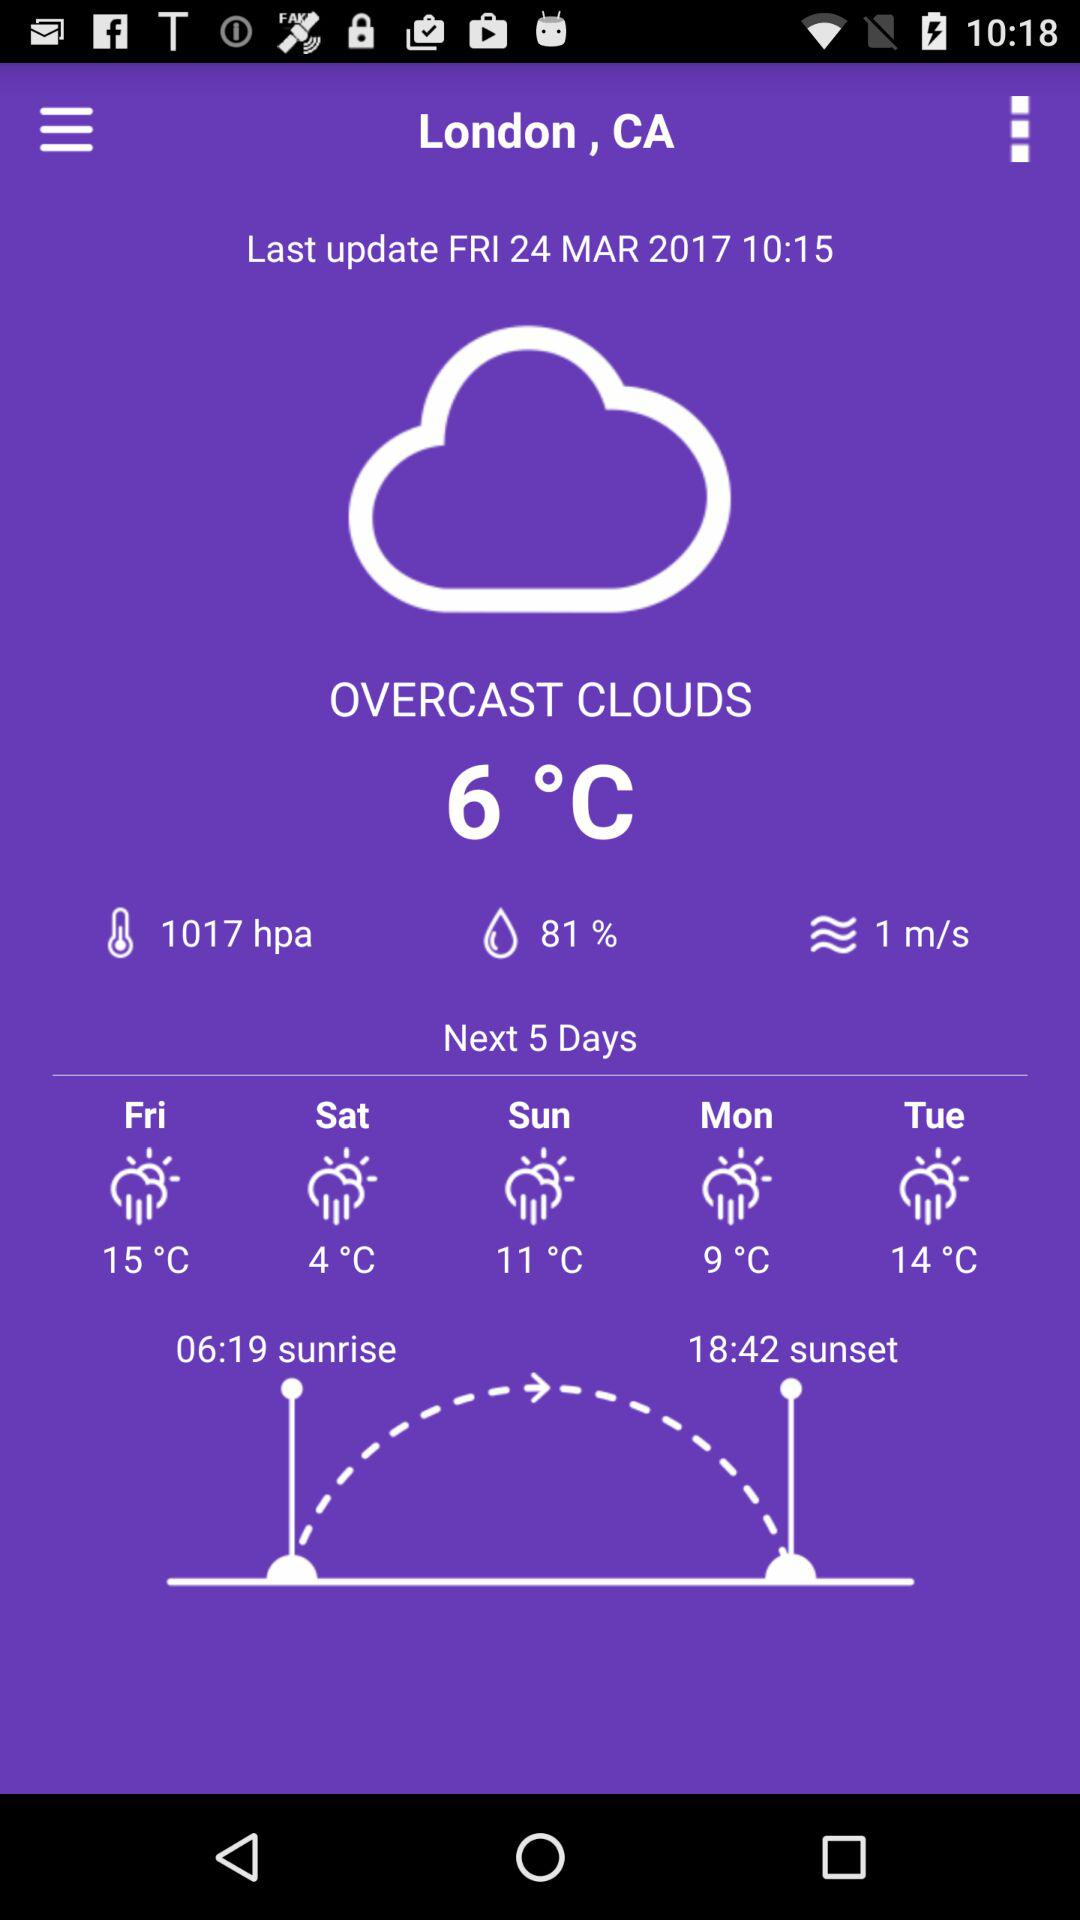What is the current location? The current location is London, CA. 